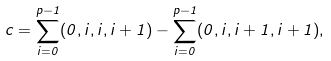<formula> <loc_0><loc_0><loc_500><loc_500>c = \sum _ { i = 0 } ^ { p - 1 } ( 0 , i , i , i + 1 ) - \sum _ { i = 0 } ^ { p - 1 } ( 0 , i , i + 1 , i + 1 ) ,</formula> 